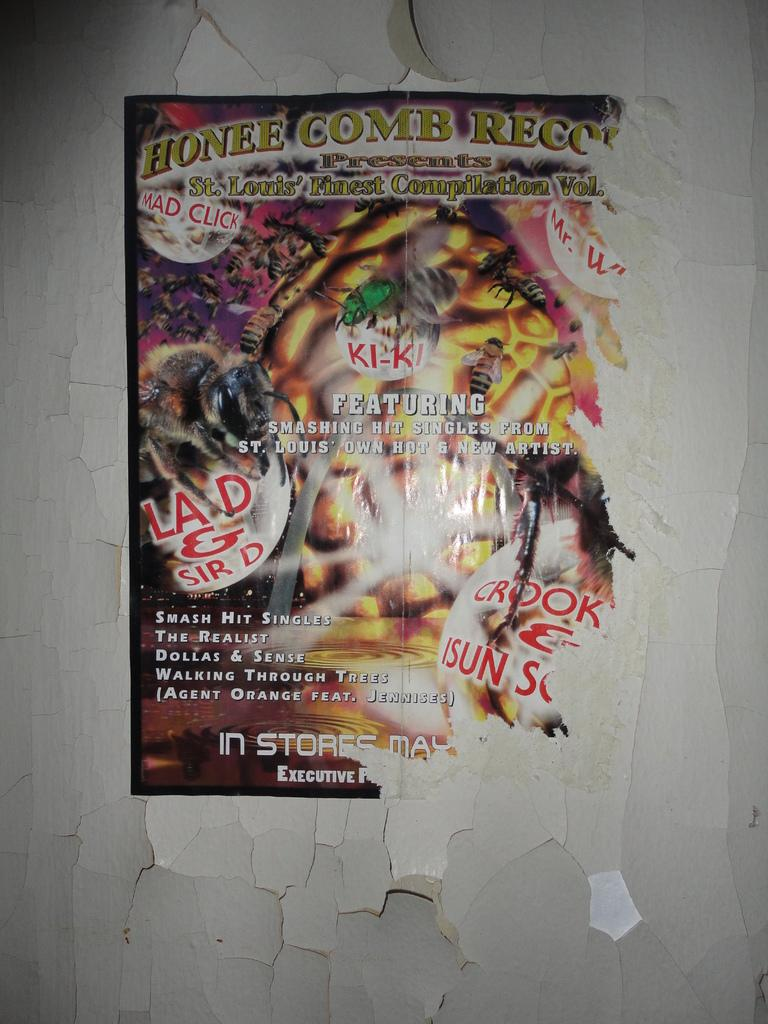What is on the wall in the image? There is a poster on the wall in the image. What can be found on the poster? The poster contains pictures and text. Are there any visible imperfections on the wall? Yes, there are cracks on the wall. What type of quiver is hanging on the wall next to the poster? There is no quiver present in the image; only the poster and cracks on the wall are visible. What error can be seen in the text on the poster? There is no mention of any errors in the text on the poster, as we cannot read the text in the image. 